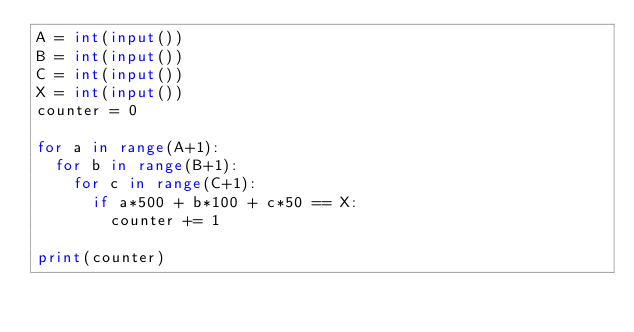<code> <loc_0><loc_0><loc_500><loc_500><_Python_>A = int(input())
B = int(input())
C = int(input())
X = int(input())
counter = 0

for a in range(A+1):
  for b in range(B+1):
    for c in range(C+1):
      if a*500 + b*100 + c*50 == X:
        counter += 1

print(counter)
</code> 